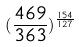<formula> <loc_0><loc_0><loc_500><loc_500>( \frac { 4 6 9 } { 3 6 3 } ) ^ { \frac { 1 5 4 } { 1 2 7 } }</formula> 